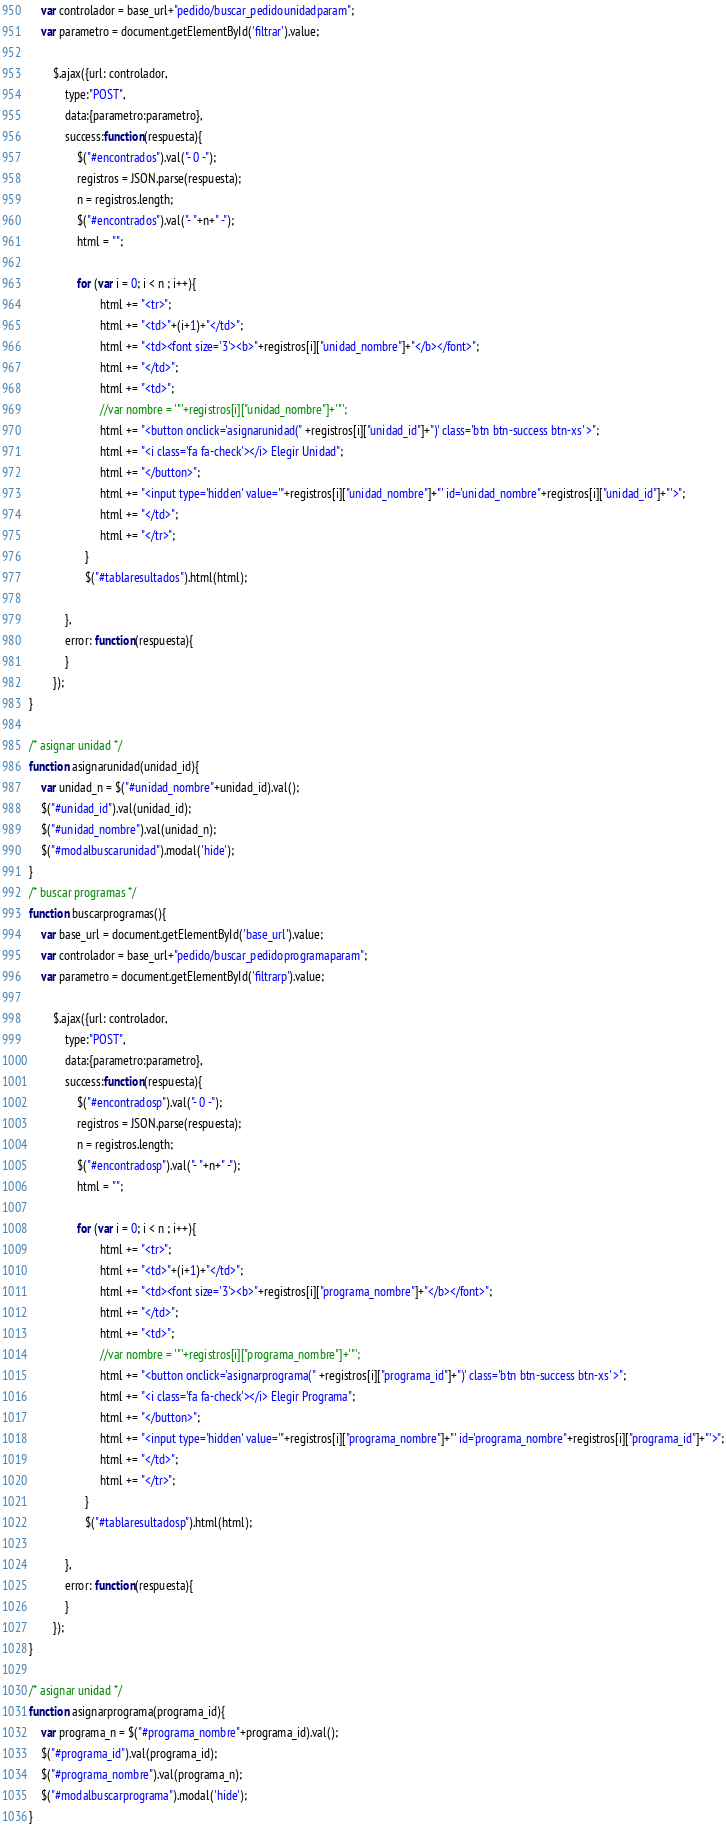Convert code to text. <code><loc_0><loc_0><loc_500><loc_500><_JavaScript_>    var controlador = base_url+"pedido/buscar_pedidounidadparam";
    var parametro = document.getElementById('filtrar').value;
    
        $.ajax({url: controlador,
            type:"POST",
            data:{parametro:parametro},
            success:function(respuesta){
                $("#encontrados").val("- 0 -");
                registros = JSON.parse(respuesta);
                n = registros.length;
                $("#encontrados").val("- "+n+" -");
                html = "";
                
                for (var i = 0; i < n ; i++){
                        html += "<tr>";
                        html += "<td>"+(i+1)+"</td>";
                        html += "<td><font size='3'><b>"+registros[i]["unidad_nombre"]+"</b></font>";
                        html += "</td>";
                        html += "<td>";
                        //var nombre = '"'+registros[i]["unidad_nombre"]+'"';
                        html += "<button onclick='asignarunidad(" +registros[i]["unidad_id"]+")' class='btn btn-success btn-xs' >";
                        html += "<i class='fa fa-check'></i> Elegir Unidad";
                        html += "</button>";
                        html += "<input type='hidden' value='"+registros[i]["unidad_nombre"]+"' id='unidad_nombre"+registros[i]["unidad_id"]+"'>";
                        html += "</td>";
                        html += "</tr>";
                   }
                   $("#tablaresultados").html(html);

            },
            error: function(respuesta){
            }
        });
}

/* asignar unidad */
function asignarunidad(unidad_id){
    var unidad_n = $("#unidad_nombre"+unidad_id).val();
    $("#unidad_id").val(unidad_id);
    $("#unidad_nombre").val(unidad_n);
    $("#modalbuscarunidad").modal('hide');
}
/* buscar programas */
function buscarprogramas(){
    var base_url = document.getElementById('base_url').value;
    var controlador = base_url+"pedido/buscar_pedidoprogramaparam";
    var parametro = document.getElementById('filtrarp').value;
    
        $.ajax({url: controlador,
            type:"POST",
            data:{parametro:parametro},
            success:function(respuesta){
                $("#encontradosp").val("- 0 -");
                registros = JSON.parse(respuesta);
                n = registros.length;
                $("#encontradosp").val("- "+n+" -");
                html = "";
                
                for (var i = 0; i < n ; i++){
                        html += "<tr>";
                        html += "<td>"+(i+1)+"</td>";
                        html += "<td><font size='3'><b>"+registros[i]["programa_nombre"]+"</b></font>";
                        html += "</td>";
                        html += "<td>";
                        //var nombre = '"'+registros[i]["programa_nombre"]+'"';
                        html += "<button onclick='asignarprograma(" +registros[i]["programa_id"]+")' class='btn btn-success btn-xs' >";
                        html += "<i class='fa fa-check'></i> Elegir Programa";
                        html += "</button>";
                        html += "<input type='hidden' value='"+registros[i]["programa_nombre"]+"' id='programa_nombre"+registros[i]["programa_id"]+"'>";
                        html += "</td>";
                        html += "</tr>";
                   }
                   $("#tablaresultadosp").html(html);

            },
            error: function(respuesta){
            }
        });
}

/* asignar unidad */
function asignarprograma(programa_id){
    var programa_n = $("#programa_nombre"+programa_id).val();
    $("#programa_id").val(programa_id);
    $("#programa_nombre").val(programa_n);
    $("#modalbuscarprograma").modal('hide');
}</code> 